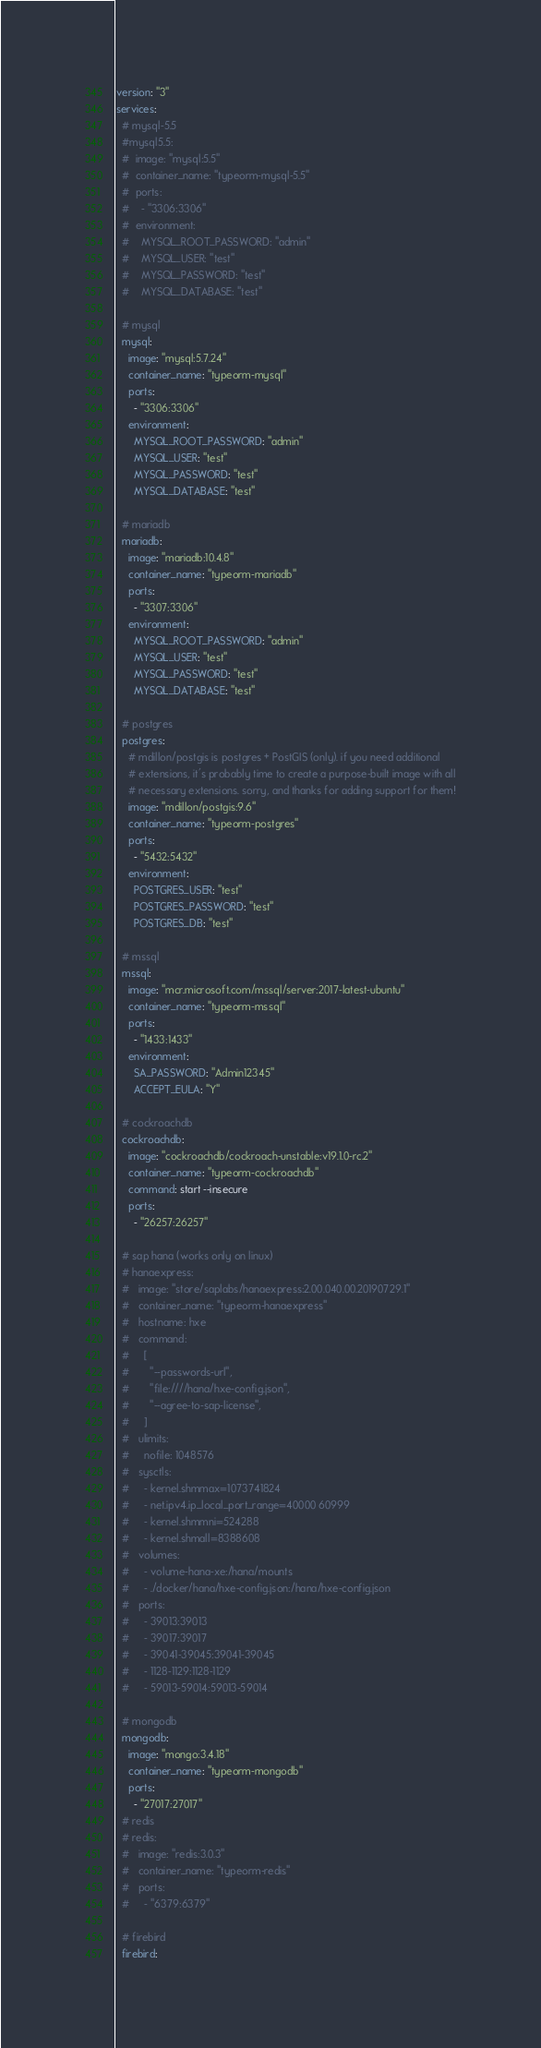Convert code to text. <code><loc_0><loc_0><loc_500><loc_500><_YAML_>version: "3"
services:
  # mysql-5.5
  #mysql5.5:
  #  image: "mysql:5.5"
  #  container_name: "typeorm-mysql-5.5"
  #  ports:
  #    - "3306:3306"
  #  environment:
  #    MYSQL_ROOT_PASSWORD: "admin"
  #    MYSQL_USER: "test"
  #    MYSQL_PASSWORD: "test"
  #    MYSQL_DATABASE: "test"

  # mysql
  mysql:
    image: "mysql:5.7.24"
    container_name: "typeorm-mysql"
    ports:
      - "3306:3306"
    environment:
      MYSQL_ROOT_PASSWORD: "admin"
      MYSQL_USER: "test"
      MYSQL_PASSWORD: "test"
      MYSQL_DATABASE: "test"

  # mariadb
  mariadb:
    image: "mariadb:10.4.8"
    container_name: "typeorm-mariadb"
    ports:
      - "3307:3306"
    environment:
      MYSQL_ROOT_PASSWORD: "admin"
      MYSQL_USER: "test"
      MYSQL_PASSWORD: "test"
      MYSQL_DATABASE: "test"

  # postgres
  postgres:
    # mdillon/postgis is postgres + PostGIS (only). if you need additional
    # extensions, it's probably time to create a purpose-built image with all
    # necessary extensions. sorry, and thanks for adding support for them!
    image: "mdillon/postgis:9.6"
    container_name: "typeorm-postgres"
    ports:
      - "5432:5432"
    environment:
      POSTGRES_USER: "test"
      POSTGRES_PASSWORD: "test"
      POSTGRES_DB: "test"

  # mssql
  mssql:
    image: "mcr.microsoft.com/mssql/server:2017-latest-ubuntu"
    container_name: "typeorm-mssql"
    ports:
      - "1433:1433"
    environment:
      SA_PASSWORD: "Admin12345"
      ACCEPT_EULA: "Y"

  # cockroachdb
  cockroachdb:
    image: "cockroachdb/cockroach-unstable:v19.1.0-rc.2"
    container_name: "typeorm-cockroachdb"
    command: start --insecure
    ports:
      - "26257:26257"

  # sap hana (works only on linux)
  # hanaexpress:
  #   image: "store/saplabs/hanaexpress:2.00.040.00.20190729.1"
  #   container_name: "typeorm-hanaexpress"
  #   hostname: hxe
  #   command:
  #     [
  #       "--passwords-url",
  #       "file:////hana/hxe-config.json",
  #       "--agree-to-sap-license",
  #     ]
  #   ulimits:
  #     nofile: 1048576
  #   sysctls:
  #     - kernel.shmmax=1073741824
  #     - net.ipv4.ip_local_port_range=40000 60999
  #     - kernel.shmmni=524288
  #     - kernel.shmall=8388608
  #   volumes:
  #     - volume-hana-xe:/hana/mounts
  #     - ./docker/hana/hxe-config.json:/hana/hxe-config.json
  #   ports:
  #     - 39013:39013
  #     - 39017:39017
  #     - 39041-39045:39041-39045
  #     - 1128-1129:1128-1129
  #     - 59013-59014:59013-59014

  # mongodb
  mongodb:
    image: "mongo:3.4.18"
    container_name: "typeorm-mongodb"
    ports:
      - "27017:27017"
  # redis
  # redis:
  #   image: "redis:3.0.3"
  #   container_name: "typeorm-redis"
  #   ports:
  #     - "6379:6379"

  # firebird
  firebird:</code> 